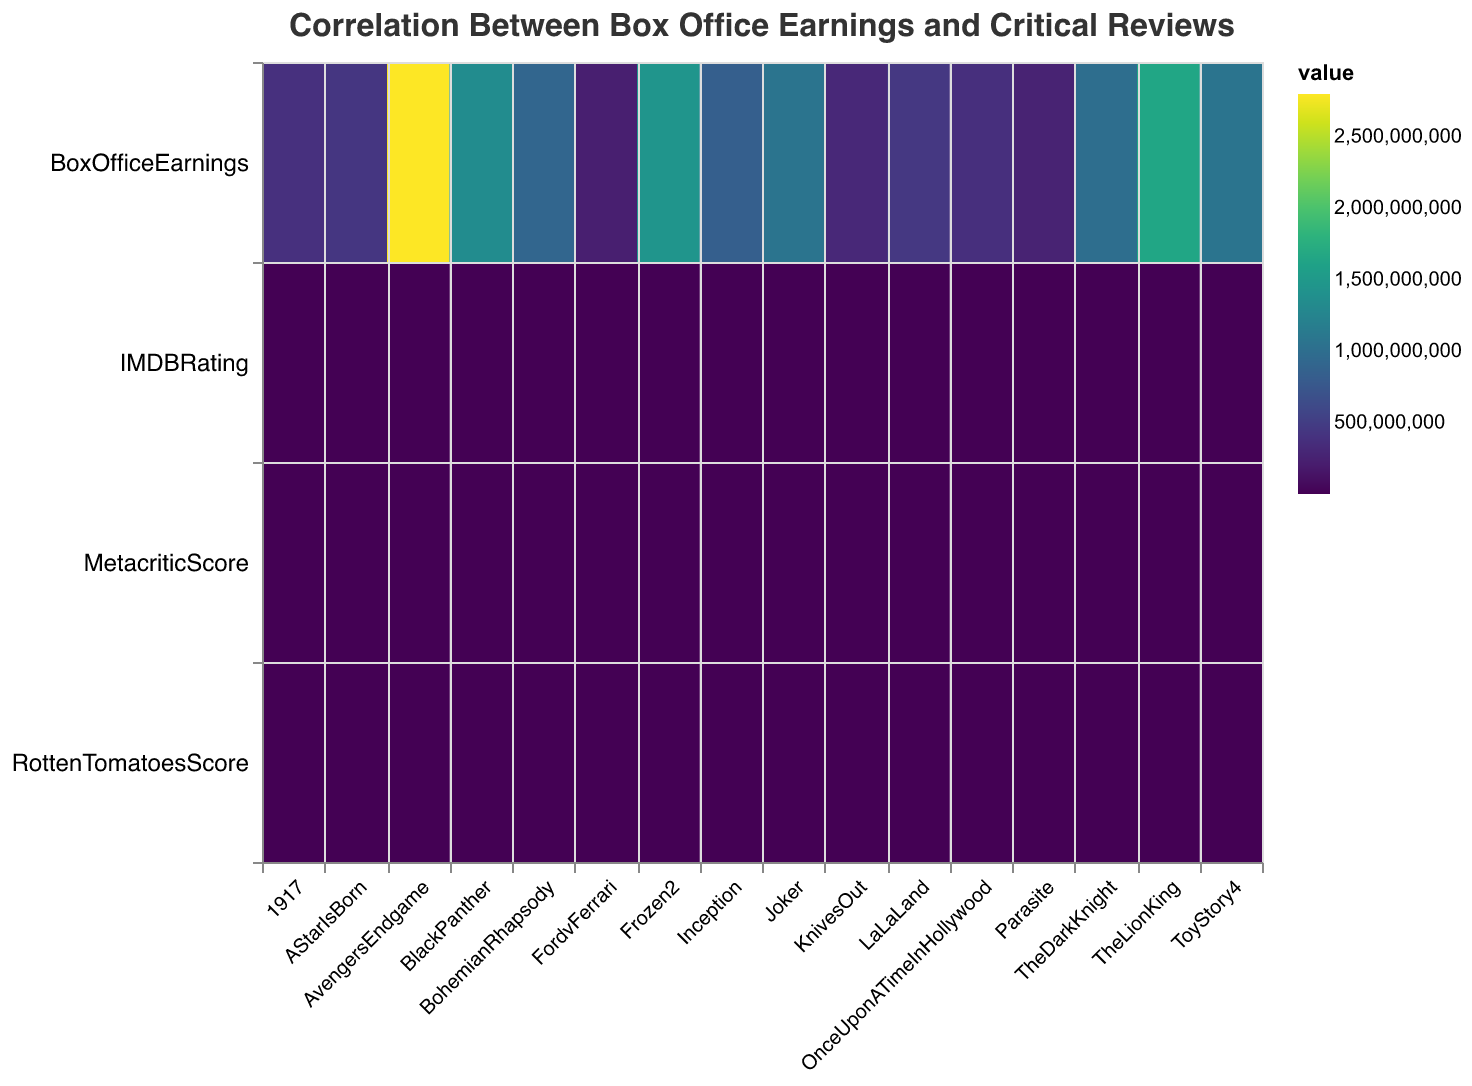Which film has the highest Box Office Earnings? Look at the color corresponding to Box Office Earnings for films on the heatmap. The film with the darkest color will have the highest earnings.
Answer: Avengers: Endgame Which film has the lowest Rotten Tomatoes score? Observe the color intensity for Rotten Tomatoes Score for each film on the heatmap. The film with the lightest color has the lowest score.
Answer: The Lion King How does the Rotten Tomatoes score of 'Parasite' compare to 'Joker'? Check the color for Rotten Tomatoes Score for both 'Parasite' and 'Joker'. 'Parasite' has a darker color in Rotten Tomatoes Score compared to 'Joker', indicating a higher score.
Answer: Parasite has a higher Rotten Tomatoes score than Joker What is the average IMDB rating across all films? Add up all the IMDB ratings from the data and divide by the number of films. (8.8 + 9.0 + 8.0 + 8.4 + 8.6 + 8.4 + 8.1 + 8.3 + 7.8 + 7.3 + 7.9 + 7.6 + 6.9 + 7.6 + 7.9 + 6.8) / 16 = 126.4 / 16 = 7.9
Answer: 7.9 Which film has the largest difference between Metacritic Score and Rotten Tomatoes Score? Calculate the difference between Metacritic Score and Rotten Tomatoes Score for each film and see which has the highest difference. For 'Parasite': 99 - 96 = 3, for 'Joker': 68 - 59 = 9, … Continue this for all films. The largest difference is for 'Bohemian Rhapsody'.
Answer: Bohemian Rhapsody What is the correlation between Box Office Earnings and Metacritic Score? Analyze the colors for Box Office Earnings and Metacritic Score across the films. The general trend and intensity can be observed to infer correlation. Darker colors in both categories for the same films indicate positive correlation.
Answer: Moderate to weak positive correlation How does 'La La Land's' Rotten Tomatoes Score compare to the other films? Look at the Rotten Tomatoes Score color for 'La La Land' and compare the intensity with other films on the heatmap. 'La La Land' has a moderately dark color, indicating a high score but not the highest.
Answer: High but not the highest Which film has the highest Metacritic Score? Check the color intensity for Metacritic Scores. The film with the darkest color in this category has the highest score.
Answer: Parasite Is there any film with a Box Office Earning below $300,000,000 but with a high Rotten Tomatoes Score? Look for films with lighter colors in Box Office Earnings and darker colors in Rotten Tomatoes Scores. 'Parasite', with earnings of $263,251,776 but a score of 99 on Rotten Tomatoes, fits this criteria.
Answer: Parasite 